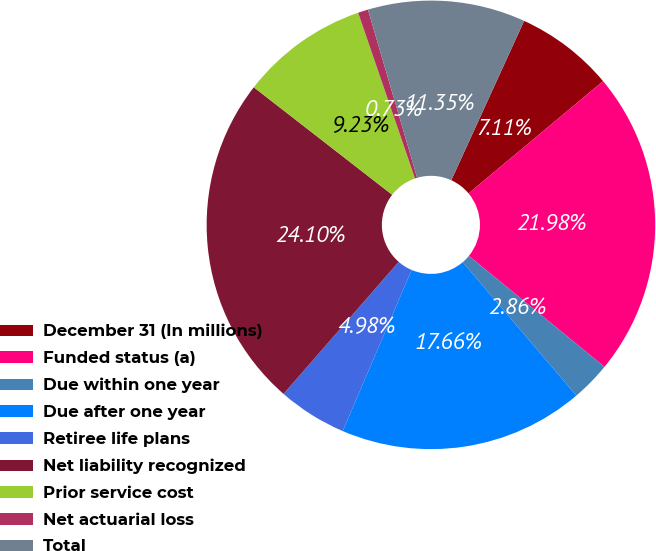Convert chart to OTSL. <chart><loc_0><loc_0><loc_500><loc_500><pie_chart><fcel>December 31 (In millions)<fcel>Funded status (a)<fcel>Due within one year<fcel>Due after one year<fcel>Retiree life plans<fcel>Net liability recognized<fcel>Prior service cost<fcel>Net actuarial loss<fcel>Total<nl><fcel>7.11%<fcel>21.98%<fcel>2.86%<fcel>17.66%<fcel>4.98%<fcel>24.1%<fcel>9.23%<fcel>0.73%<fcel>11.35%<nl></chart> 